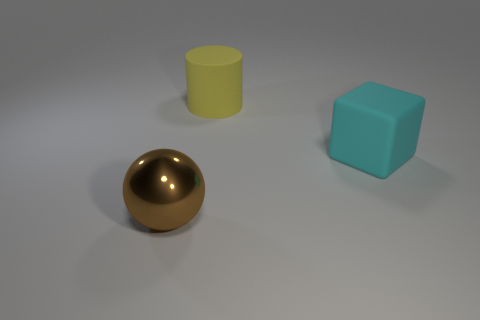What material is the large object that is to the right of the large yellow cylinder?
Offer a terse response. Rubber. Is there a big rubber block that has the same color as the metallic ball?
Ensure brevity in your answer.  No. What color is the cube that is the same size as the metal object?
Offer a very short reply. Cyan. What number of small objects are either yellow cylinders or cubes?
Provide a short and direct response. 0. Are there an equal number of cubes that are in front of the cyan rubber thing and cyan rubber cubes on the left side of the brown shiny ball?
Provide a short and direct response. Yes. How many cyan matte things have the same size as the yellow rubber object?
Offer a terse response. 1. What number of cyan things are either large matte cubes or big shiny objects?
Make the answer very short. 1. Is the number of brown spheres in front of the large shiny thing the same as the number of yellow things?
Your answer should be very brief. No. How big is the matte object that is in front of the large yellow thing?
Offer a very short reply. Large. What number of other brown metal things are the same shape as the brown shiny thing?
Keep it short and to the point. 0. 